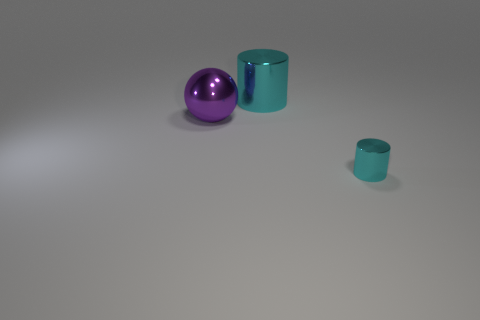What number of objects are small purple cubes or big cylinders? In the image, there are no small purple cubes; however, there are two cylinders, one of which is large. So, to answer your question, there is 1 big cylinder. 